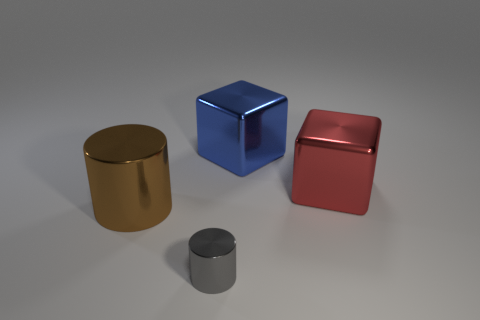What materials do the objects in the image seem to be made of? The objects in the image have a metallic appearance, indicating they might be made of a type of polished metal, such as aluminum or steel, to achieve that reflective surface. 